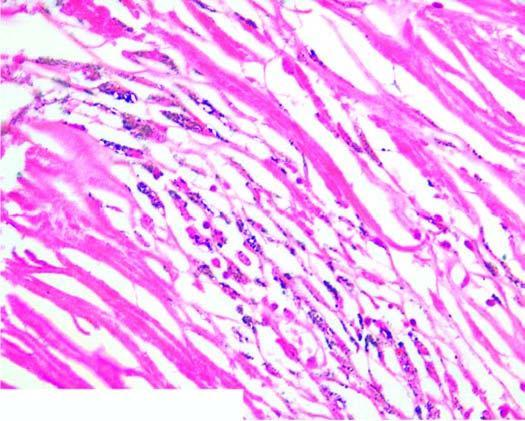does the silicotic nodule consist of hyaline centre surrounded by concentric layers of collagen which are further enclosed by fibroblasts and dust-laden macrophages?
Answer the question using a single word or phrase. Yes 